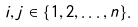Convert formula to latex. <formula><loc_0><loc_0><loc_500><loc_500>i , j \in \{ 1 , 2 , \dots , n \} .</formula> 